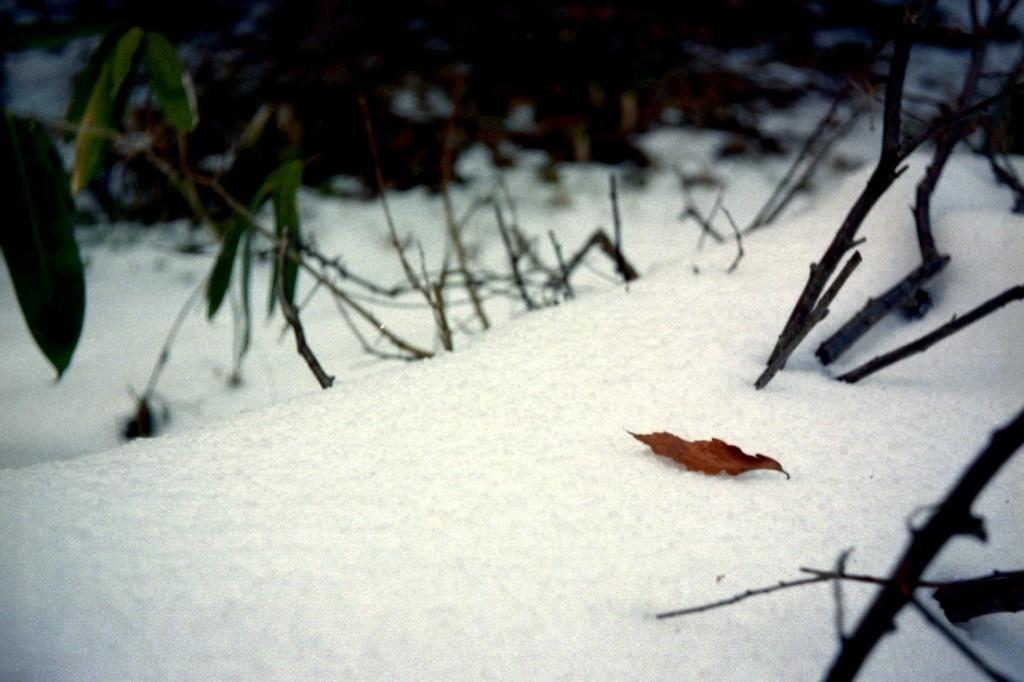What is the main subject in the center of the image? There is a dry leaf in the center of the image. Where is the dry leaf located? The dry leaf is on the ground. What can be seen in the background of the image? There is a plant in the background of the image. What is present on the right side of the image? There are branches on the right side of the image. What is the condition of the ground in the image? There is snow on the ground in the image. What type of clover can be seen growing near the branches in the image? There is no clover present in the image; the right side of the image features branches, not clover. 